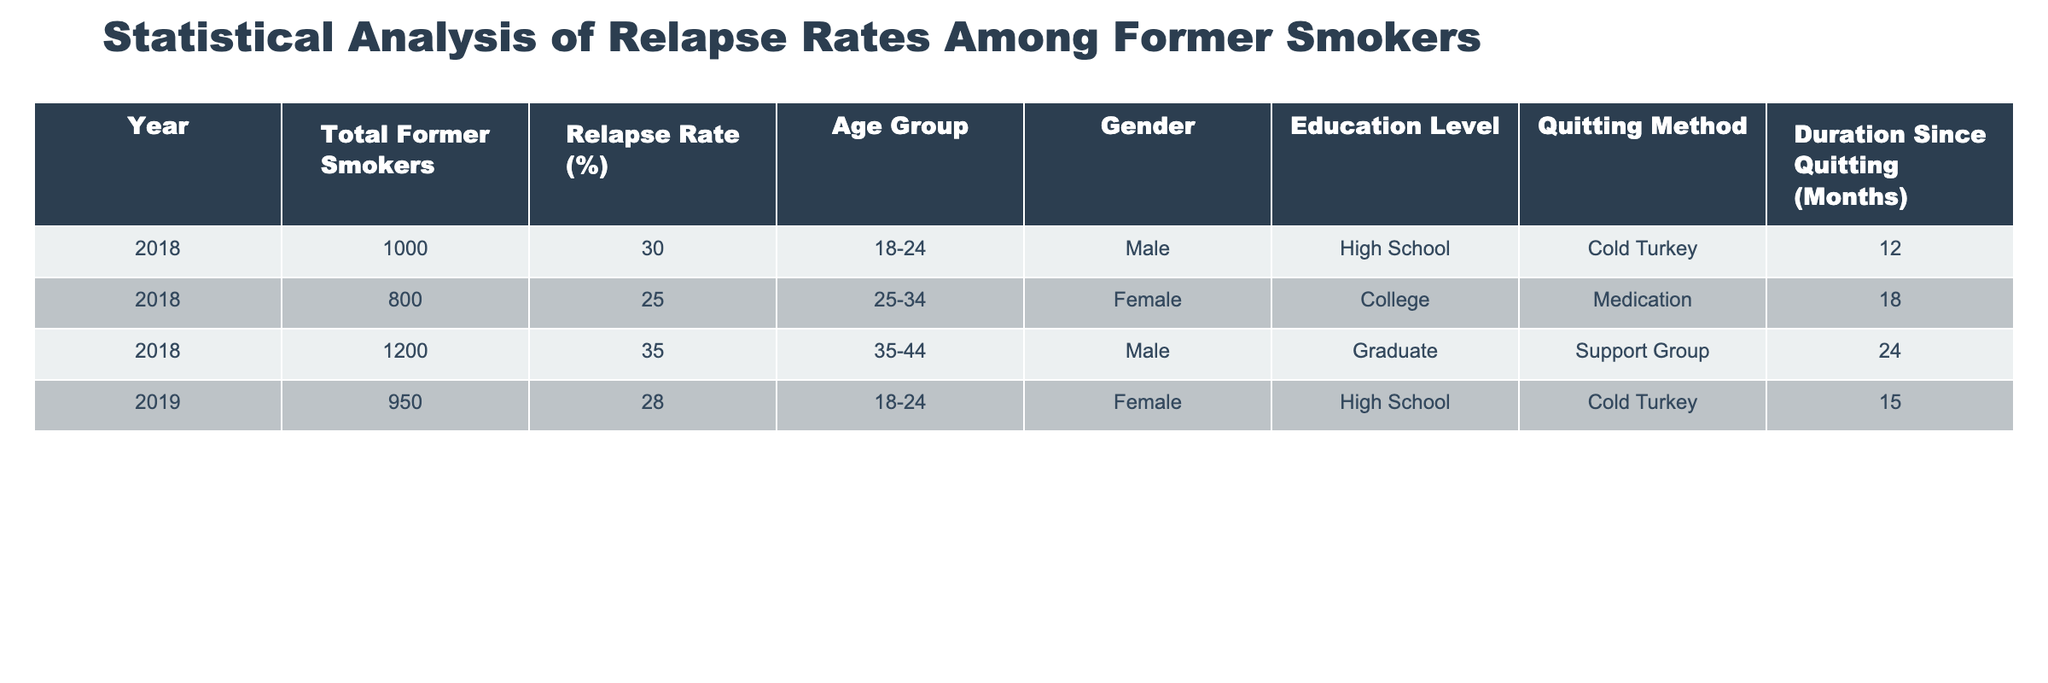What is the highest relapse rate recorded in the table? By examining the 'Relapse Rate (%)' column, the highest value is 35% in the year 2018 for the age group 35-44 and gender male.
Answer: 35% What is the total number of former smokers surveyed in 2019? Looking at the 'Total Former Smokers' column for the year 2019, there is one entry with a value of 950. Therefore, the total for that year is 950.
Answer: 950 Which gender has a higher average relapse rate? Calculate the average relapse rate for each gender. Males have rates of 30% and 35% (average = 32.5%), while females have rates of 25% and 28% (average = 26.5%). Males have a higher average relapse rate.
Answer: Males Is there any former smoker who quit using the medication method? Reviewing the 'Quitting Method' column, there is one entry indicating that a female former smoker used medication in 2018.
Answer: Yes What is the average duration since quitting among former smokers in the age group 18-24? For the age group 18-24, there are two entries: one with 12 months and another with 15 months. To find the average, sum 12 and 15 to get 27, then divide by 2 to obtain 13.5 months.
Answer: 13.5 months How many former smokers in the 25-34 age group relapsed? The 'Total Former Smokers' for the 25-34 age group shows 800, with a relapse rate of 25%. To find the number of relapses, multiply 800 by 0.25 (800 * 0.25 = 200).
Answer: 200 What is the difference in relapse rates between males and females in 2018? In 2018, males had a relapse rate of 30% and females had a rate of 25%. The difference is calculated as 30% - 25% = 5%.
Answer: 5% Which quitting method had the lowest relapse rate of the entries in the table? Reviewing the 'Quitting Method' and associated 'Relapse Rate (%)', the lowest rate is 25% for those using the medication method.
Answer: Medication What is the total relapse rate across all entries for the year 2018? To find the total relapse rate, review the rates for 2018: they are 30%, 25%, and 35%. Add them together (30 + 25 + 35 = 90) then divide by the number of entries (3) to give an average of 30%.
Answer: 30% Is there a trend in relapse rates based on the duration since quitting? Analyzing the data, as the duration since quitting increases (from 12 months to 24 months), the relapse rates also vary but not uniformly. The average scores do not indicate a clear upward or downward trend across provided data.
Answer: No clear trend 